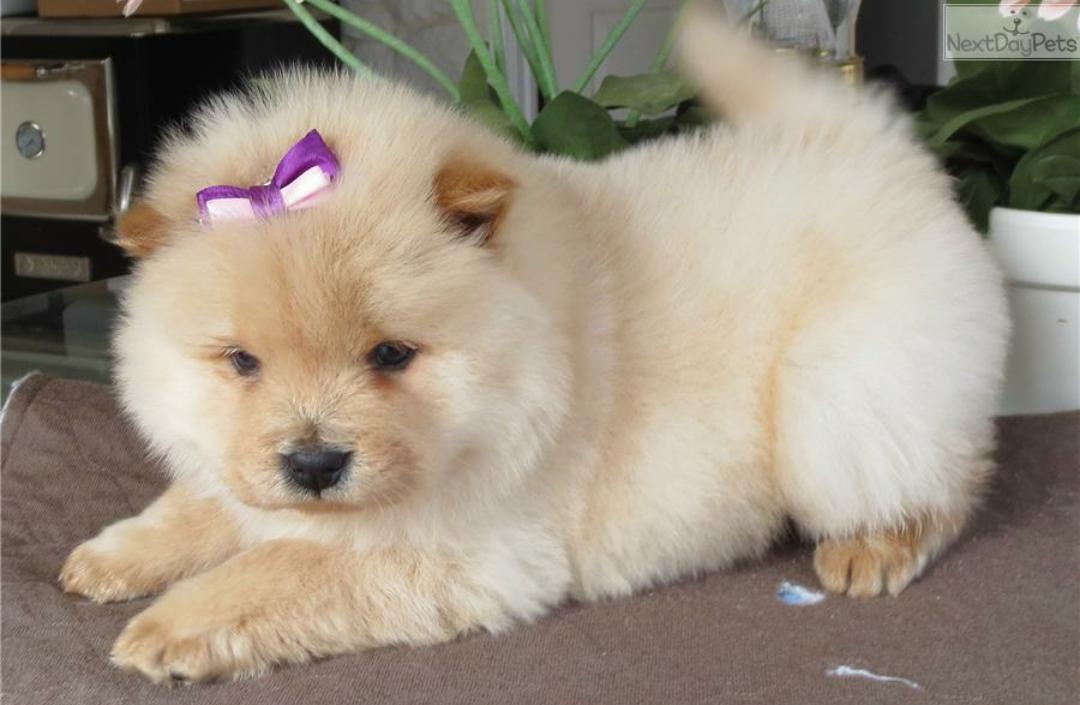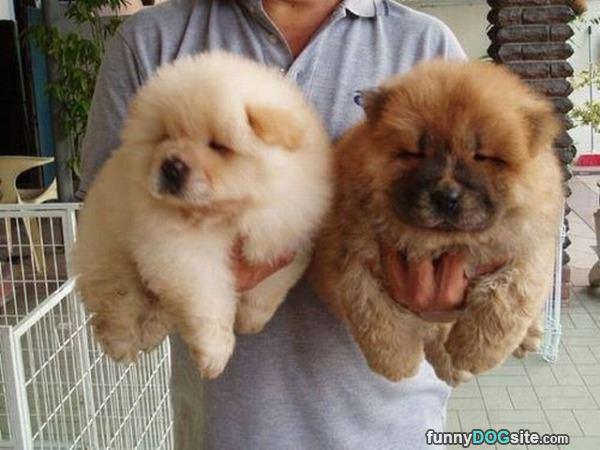The first image is the image on the left, the second image is the image on the right. Examine the images to the left and right. Is the description "There are no more than 3 dogs." accurate? Answer yes or no. Yes. The first image is the image on the left, the second image is the image on the right. Examine the images to the left and right. Is the description "There is at most 3 dogs." accurate? Answer yes or no. Yes. 